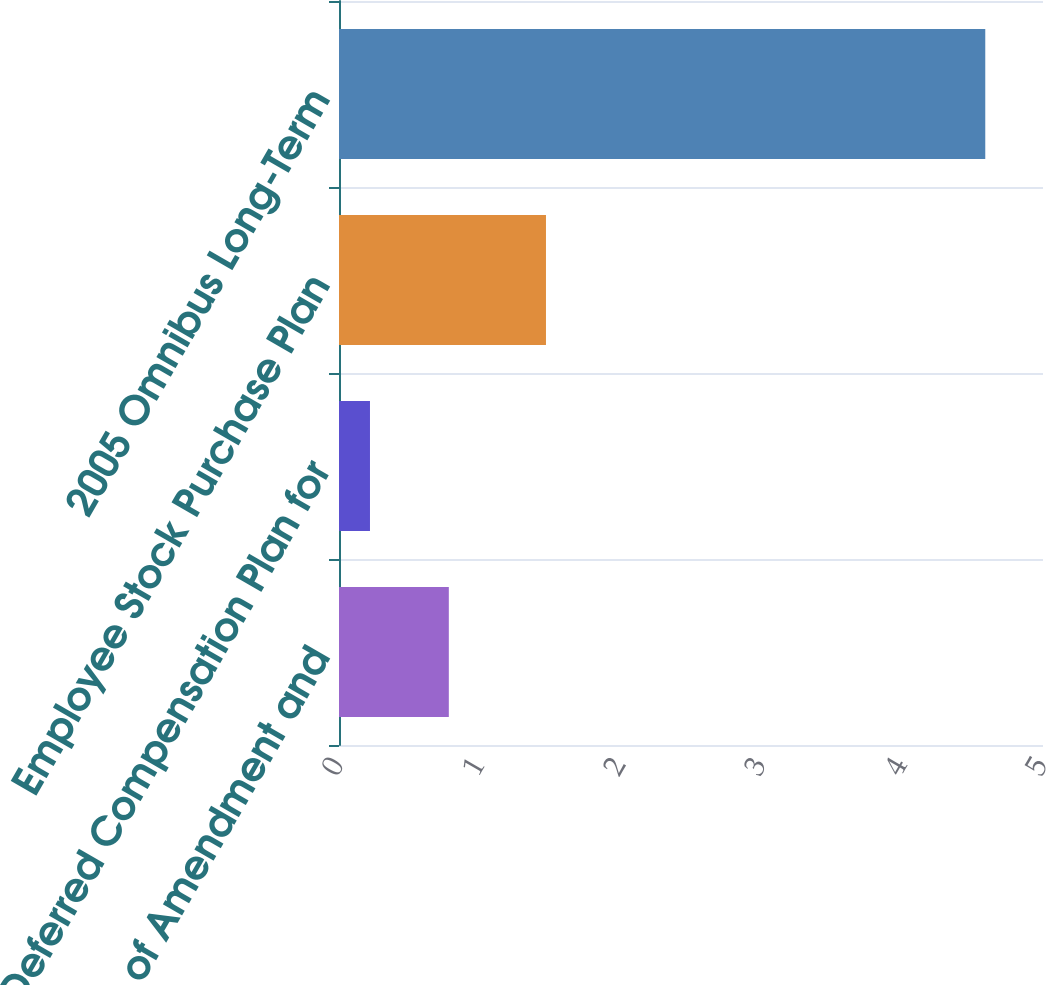Convert chart to OTSL. <chart><loc_0><loc_0><loc_500><loc_500><bar_chart><fcel>Articles of Amendment and<fcel>Deferred Compensation Plan for<fcel>Employee Stock Purchase Plan<fcel>2005 Omnibus Long-Term<nl><fcel>0.78<fcel>0.22<fcel>1.47<fcel>4.59<nl></chart> 